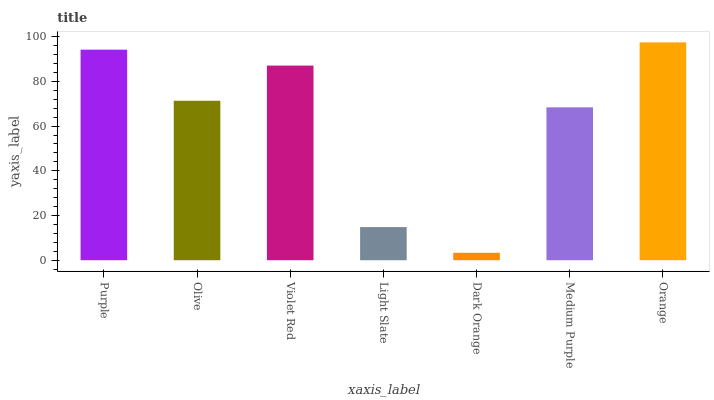Is Olive the minimum?
Answer yes or no. No. Is Olive the maximum?
Answer yes or no. No. Is Purple greater than Olive?
Answer yes or no. Yes. Is Olive less than Purple?
Answer yes or no. Yes. Is Olive greater than Purple?
Answer yes or no. No. Is Purple less than Olive?
Answer yes or no. No. Is Olive the high median?
Answer yes or no. Yes. Is Olive the low median?
Answer yes or no. Yes. Is Orange the high median?
Answer yes or no. No. Is Light Slate the low median?
Answer yes or no. No. 